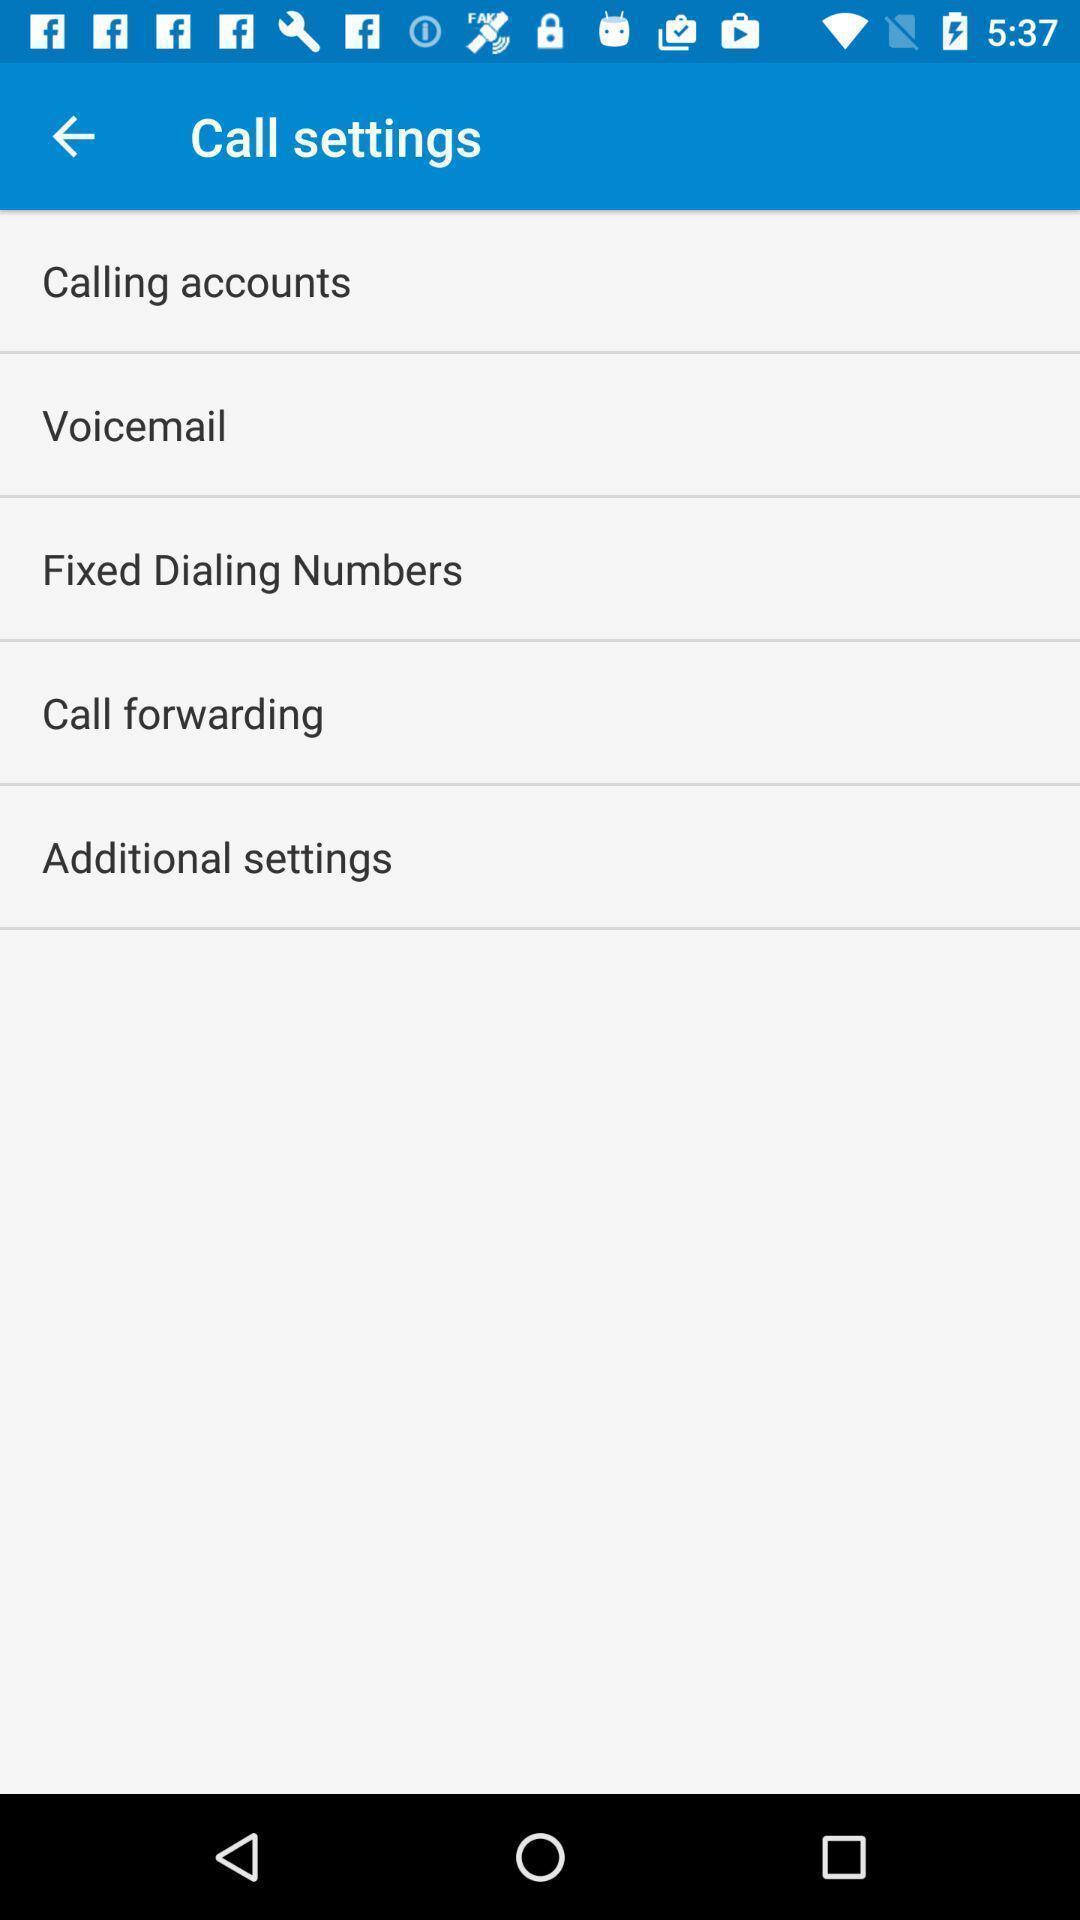Provide a textual representation of this image. Settings page with various options. 